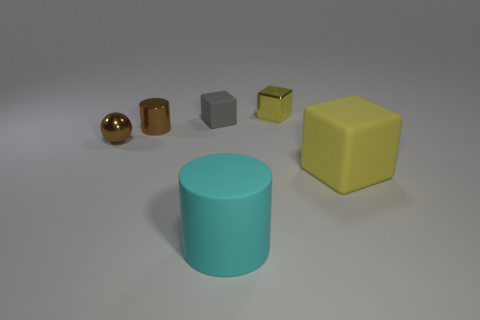Subtract all small matte cubes. How many cubes are left? 2 Subtract 2 cylinders. How many cylinders are left? 0 Subtract all red cylinders. How many blue cubes are left? 0 Subtract all small purple cubes. Subtract all small metallic balls. How many objects are left? 5 Add 2 cylinders. How many cylinders are left? 4 Add 6 cyan things. How many cyan things exist? 7 Add 1 blue matte cylinders. How many objects exist? 7 Subtract all cyan cylinders. How many cylinders are left? 1 Subtract 1 brown cylinders. How many objects are left? 5 Subtract all cylinders. How many objects are left? 4 